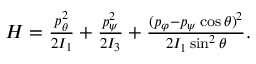Convert formula to latex. <formula><loc_0><loc_0><loc_500><loc_500>\begin{array} { r } { H = \frac { p _ { \theta } ^ { 2 } } { 2 I _ { 1 } } + \frac { p _ { \psi } ^ { 2 } } { 2 I _ { 3 } } + \frac { ( p _ { \varphi } - p _ { \psi } \cos \theta ) ^ { 2 } } { 2 I _ { 1 } \sin ^ { 2 } \theta } . } \end{array}</formula> 